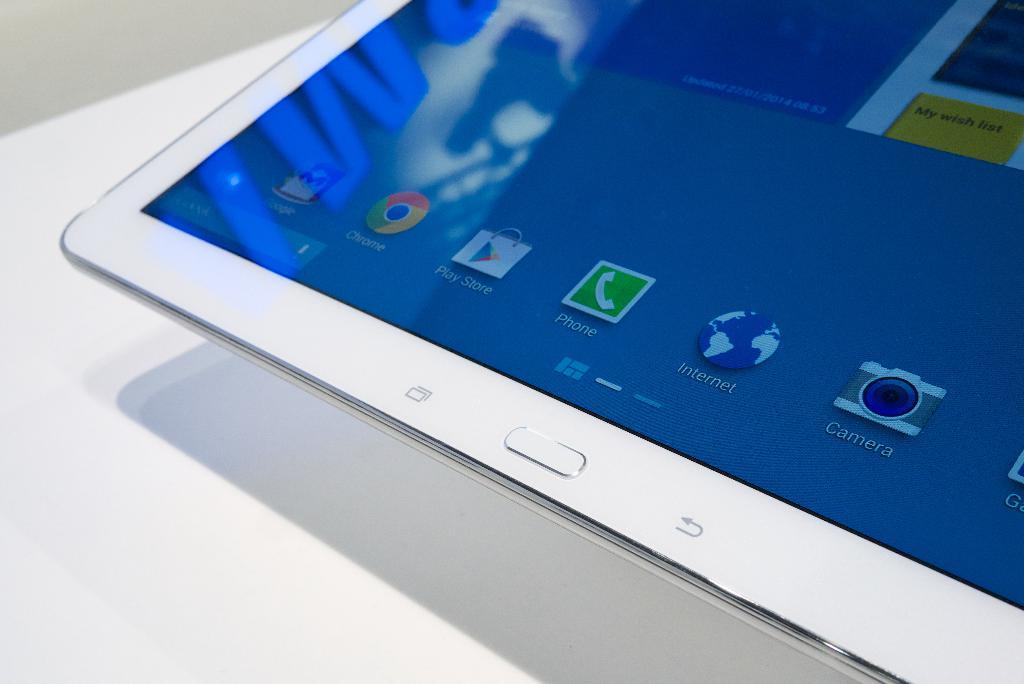What is the main object in the image? There is a screen in the image. What color is the surface that the screen is placed on? There is a white colored surface in the image. What can be observed on the white surface due to the presence of the screen? The shadow of the screen is visible on the white colored surface. What type of muscle is being exercised by the screen in the image? There is no muscle being exercised by the screen in the image. 